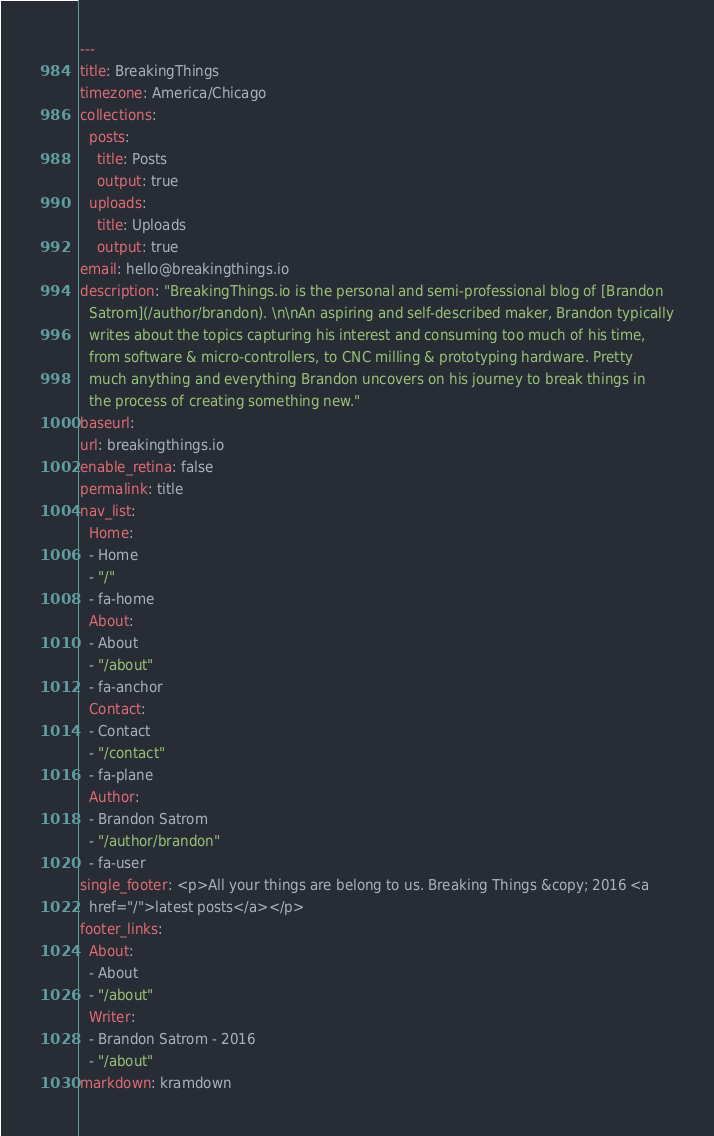<code> <loc_0><loc_0><loc_500><loc_500><_YAML_>---
title: BreakingThings
timezone: America/Chicago
collections:
  posts:
    title: Posts
    output: true
  uploads:
    title: Uploads
    output: true
email: hello@breakingthings.io
description: "BreakingThings.io is the personal and semi-professional blog of [Brandon
  Satrom](/author/brandon). \n\nAn aspiring and self-described maker, Brandon typically
  writes about the topics capturing his interest and consuming too much of his time,
  from software & micro-controllers, to CNC milling & prototyping hardware. Pretty
  much anything and everything Brandon uncovers on his journey to break things in
  the process of creating something new."
baseurl: 
url: breakingthings.io
enable_retina: false
permalink: title
nav_list:
  Home:
  - Home
  - "/"
  - fa-home
  About:
  - About
  - "/about"
  - fa-anchor
  Contact:
  - Contact
  - "/contact"
  - fa-plane
  Author:
  - Brandon Satrom
  - "/author/brandon"
  - fa-user
single_footer: <p>All your things are belong to us. Breaking Things &copy; 2016 <a
  href="/">latest posts</a></p>
footer_links:
  About:
  - About
  - "/about"
  Writer:
  - Brandon Satrom - 2016
  - "/about"
markdown: kramdown
</code> 